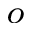Convert formula to latex. <formula><loc_0><loc_0><loc_500><loc_500>^ { o }</formula> 